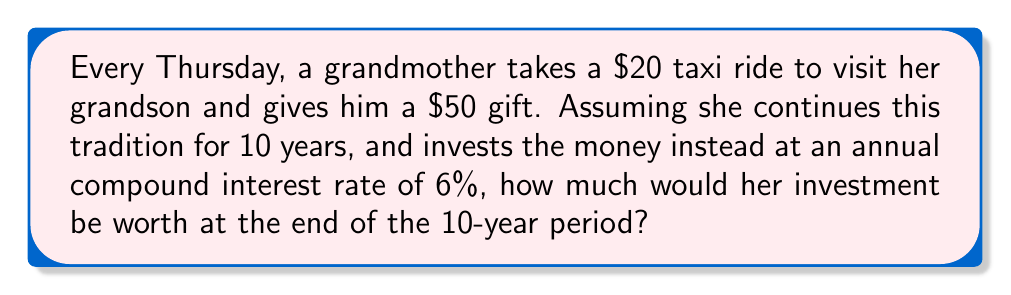Show me your answer to this math problem. To solve this problem, we need to follow these steps:

1. Calculate the total weekly cost:
   Taxi fare + Gift = $20 + $50 = $70 per week

2. Calculate the annual cost:
   $70 × 52 weeks = $3,640 per year

3. Use the compound interest formula to calculate the future value of this annual investment:

   $$FV = PMT \times \frac{(1 + r)^n - 1}{r}$$

   Where:
   FV = Future Value
   PMT = Annual Payment (investment)
   r = Annual interest rate
   n = Number of years

4. Plug in the values:
   PMT = $3,640
   r = 6% = 0.06
   n = 10 years

   $$FV = 3640 \times \frac{(1 + 0.06)^{10} - 1}{0.06}$$

5. Calculate:
   $$FV = 3640 \times \frac{1.7908 - 1}{0.06}$$
   $$FV = 3640 \times 13.1804$$
   $$FV = 47,976.66$$

Therefore, if the grandmother invested the money instead of spending it on taxi fares and gifts, she would have $47,976.66 after 10 years.
Answer: $47,976.66 